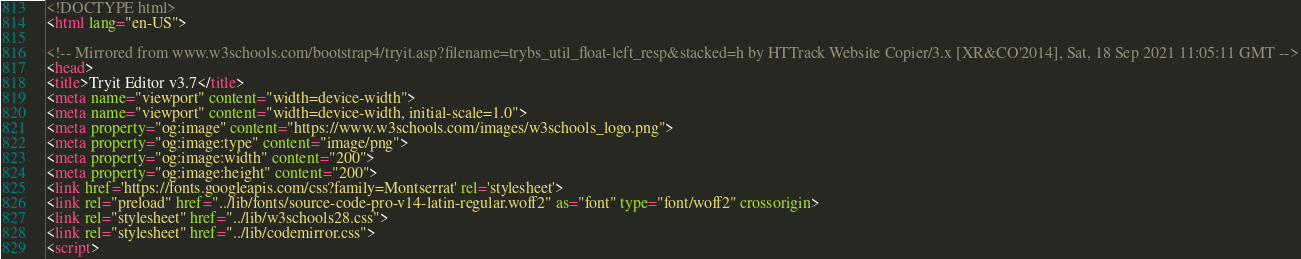Convert code to text. <code><loc_0><loc_0><loc_500><loc_500><_HTML_>
<!DOCTYPE html>
<html lang="en-US">

<!-- Mirrored from www.w3schools.com/bootstrap4/tryit.asp?filename=trybs_util_float-left_resp&stacked=h by HTTrack Website Copier/3.x [XR&CO'2014], Sat, 18 Sep 2021 11:05:11 GMT -->
<head>
<title>Tryit Editor v3.7</title>
<meta name="viewport" content="width=device-width">
<meta name="viewport" content="width=device-width, initial-scale=1.0">
<meta property="og:image" content="https://www.w3schools.com/images/w3schools_logo.png">
<meta property="og:image:type" content="image/png">
<meta property="og:image:width" content="200">
<meta property="og:image:height" content="200">
<link href='https://fonts.googleapis.com/css?family=Montserrat' rel='stylesheet'>
<link rel="preload" href="../lib/fonts/source-code-pro-v14-latin-regular.woff2" as="font" type="font/woff2" crossorigin>
<link rel="stylesheet" href="../lib/w3schools28.css">
<link rel="stylesheet" href="../lib/codemirror.css">
<script></code> 